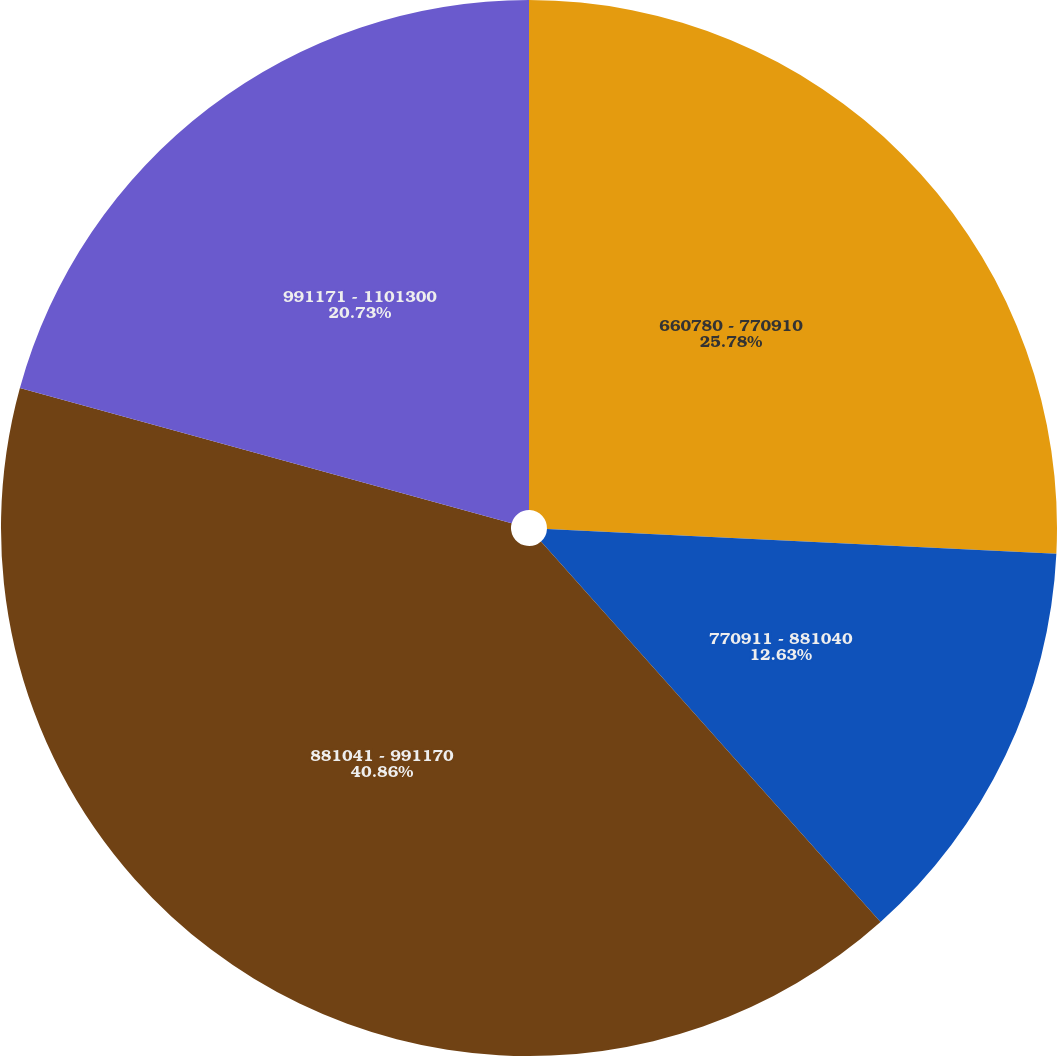Convert chart to OTSL. <chart><loc_0><loc_0><loc_500><loc_500><pie_chart><fcel>660780 - 770910<fcel>770911 - 881040<fcel>881041 - 991170<fcel>991171 - 1101300<nl><fcel>25.78%<fcel>12.63%<fcel>40.87%<fcel>20.73%<nl></chart> 